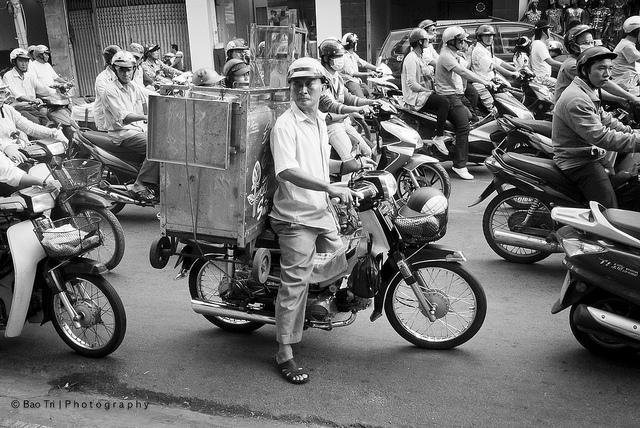Please transcribe the text information in this image. Photography 